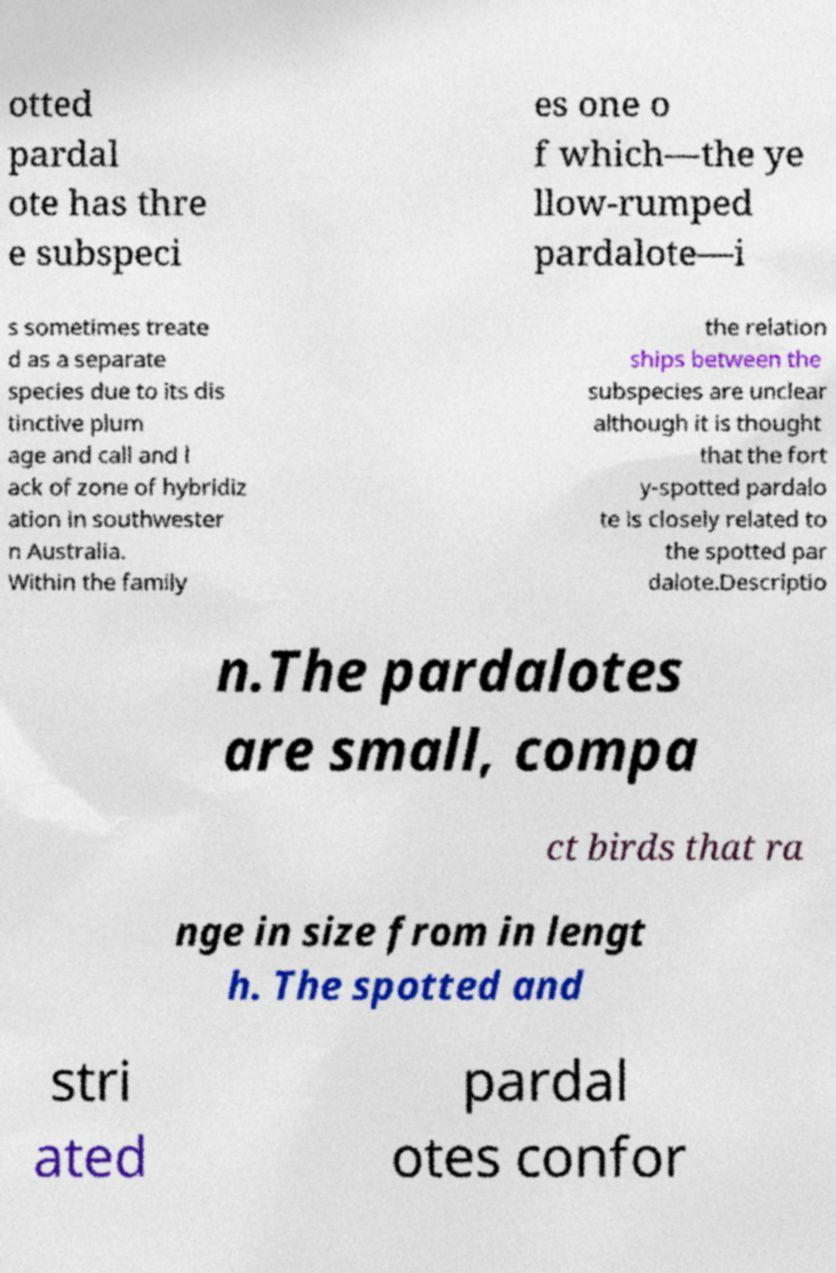For documentation purposes, I need the text within this image transcribed. Could you provide that? otted pardal ote has thre e subspeci es one o f which—the ye llow-rumped pardalote—i s sometimes treate d as a separate species due to its dis tinctive plum age and call and l ack of zone of hybridiz ation in southwester n Australia. Within the family the relation ships between the subspecies are unclear although it is thought that the fort y-spotted pardalo te is closely related to the spotted par dalote.Descriptio n.The pardalotes are small, compa ct birds that ra nge in size from in lengt h. The spotted and stri ated pardal otes confor 